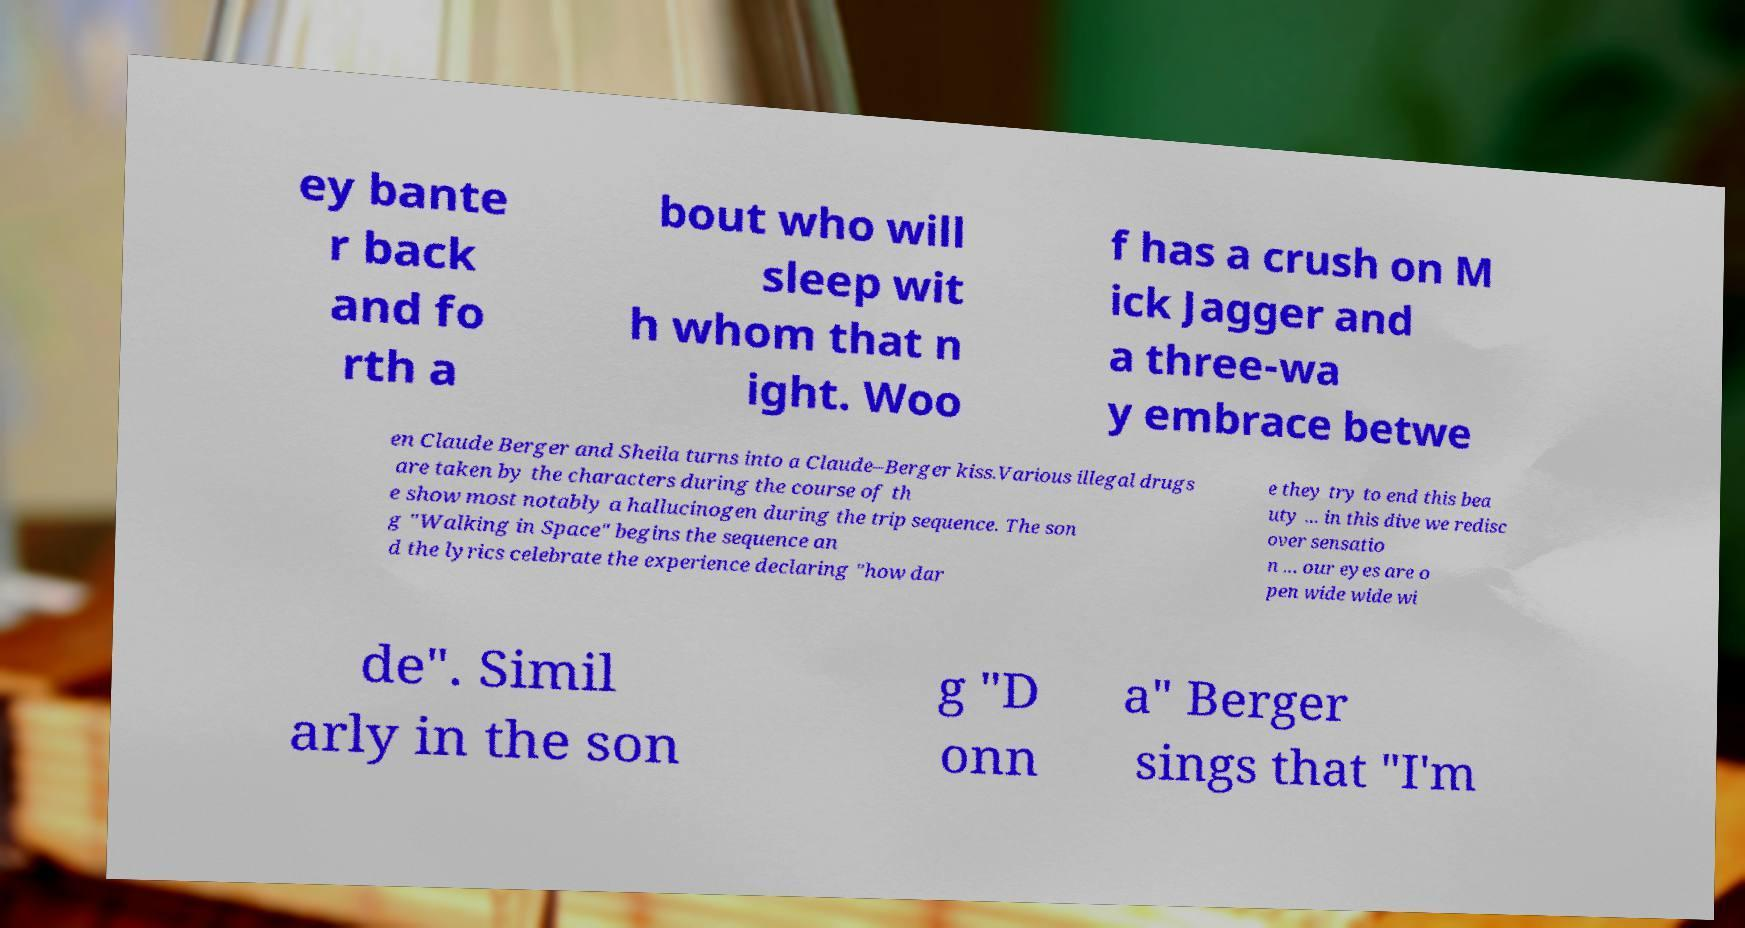I need the written content from this picture converted into text. Can you do that? ey bante r back and fo rth a bout who will sleep wit h whom that n ight. Woo f has a crush on M ick Jagger and a three-wa y embrace betwe en Claude Berger and Sheila turns into a Claude–Berger kiss.Various illegal drugs are taken by the characters during the course of th e show most notably a hallucinogen during the trip sequence. The son g "Walking in Space" begins the sequence an d the lyrics celebrate the experience declaring "how dar e they try to end this bea uty ... in this dive we redisc over sensatio n ... our eyes are o pen wide wide wi de". Simil arly in the son g "D onn a" Berger sings that "I'm 